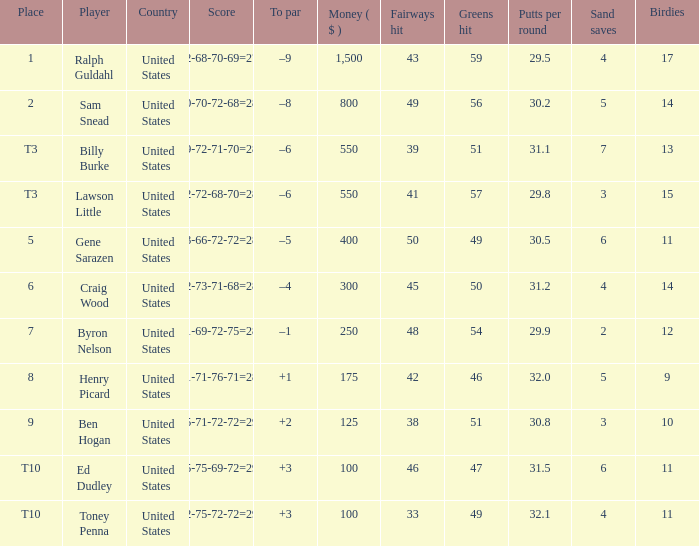Which score comes with a $400 prize? 73-66-72-72=283. 